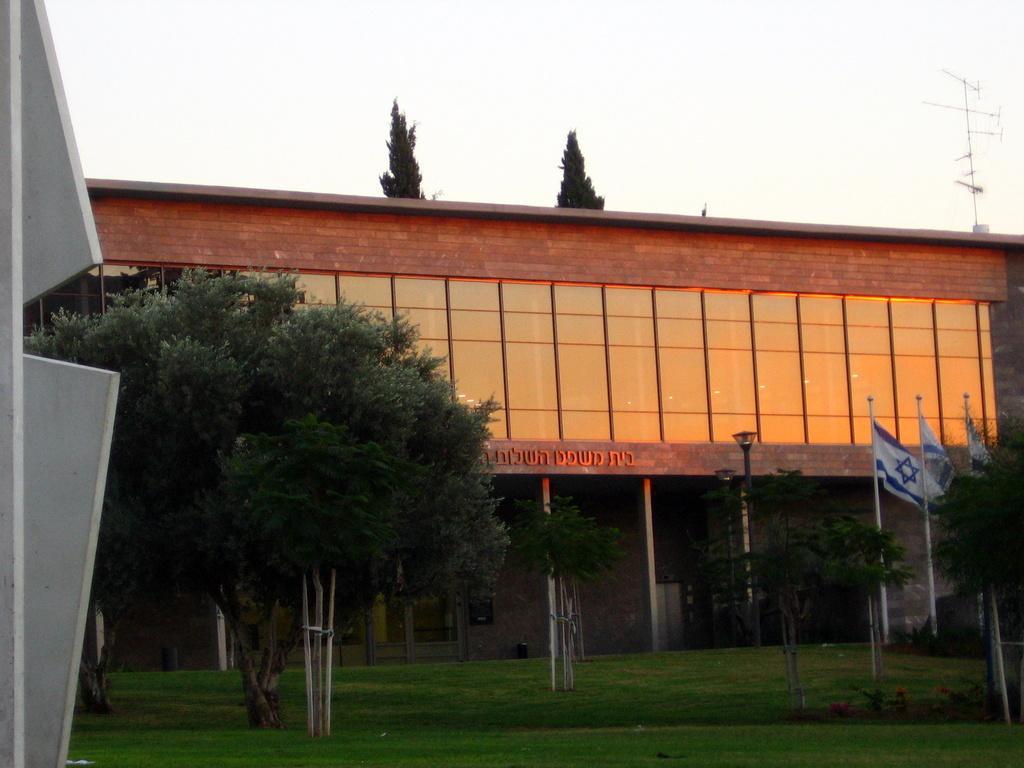How would you summarize this image in a sentence or two? In this image we can see a building. We can also see some grass, poles, a street lamp, the flags, a group of trees, an antenna and the sky which looks cloudy. On the left side we can see a metal stand. 